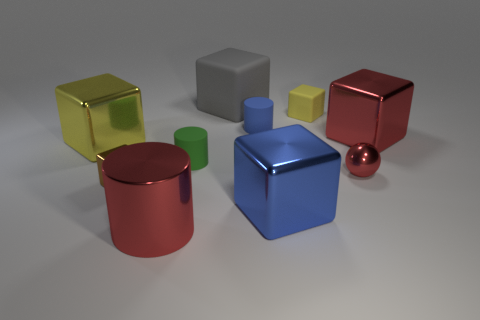Subtract 1 cubes. How many cubes are left? 5 Subtract all brown cubes. How many cubes are left? 5 Subtract all blue metal blocks. How many blocks are left? 5 Subtract all purple blocks. Subtract all gray cylinders. How many blocks are left? 6 Subtract all balls. How many objects are left? 9 Subtract 1 red cubes. How many objects are left? 9 Subtract all large cyan metal balls. Subtract all big red metallic things. How many objects are left? 8 Add 2 red metal objects. How many red metal objects are left? 5 Add 8 cyan objects. How many cyan objects exist? 8 